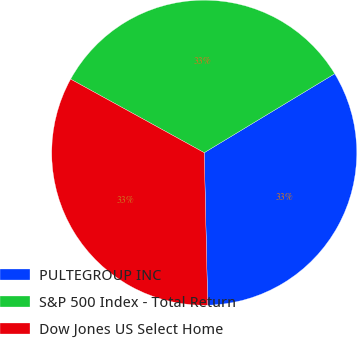<chart> <loc_0><loc_0><loc_500><loc_500><pie_chart><fcel>PULTEGROUP INC<fcel>S&P 500 Index - Total Return<fcel>Dow Jones US Select Home<nl><fcel>33.3%<fcel>33.33%<fcel>33.37%<nl></chart> 